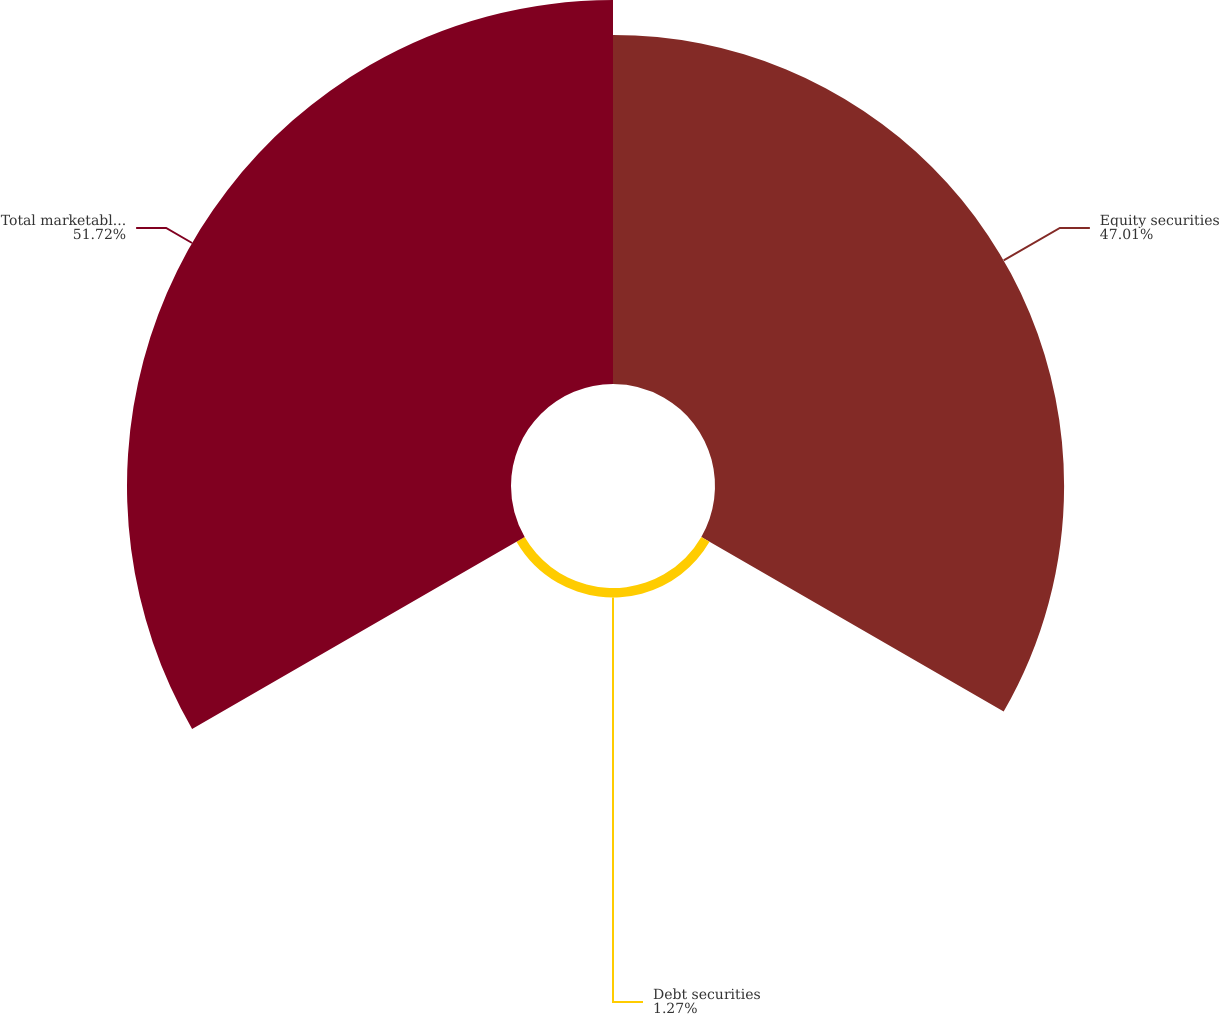Convert chart to OTSL. <chart><loc_0><loc_0><loc_500><loc_500><pie_chart><fcel>Equity securities<fcel>Debt securities<fcel>Total marketable securities<nl><fcel>47.01%<fcel>1.27%<fcel>51.71%<nl></chart> 